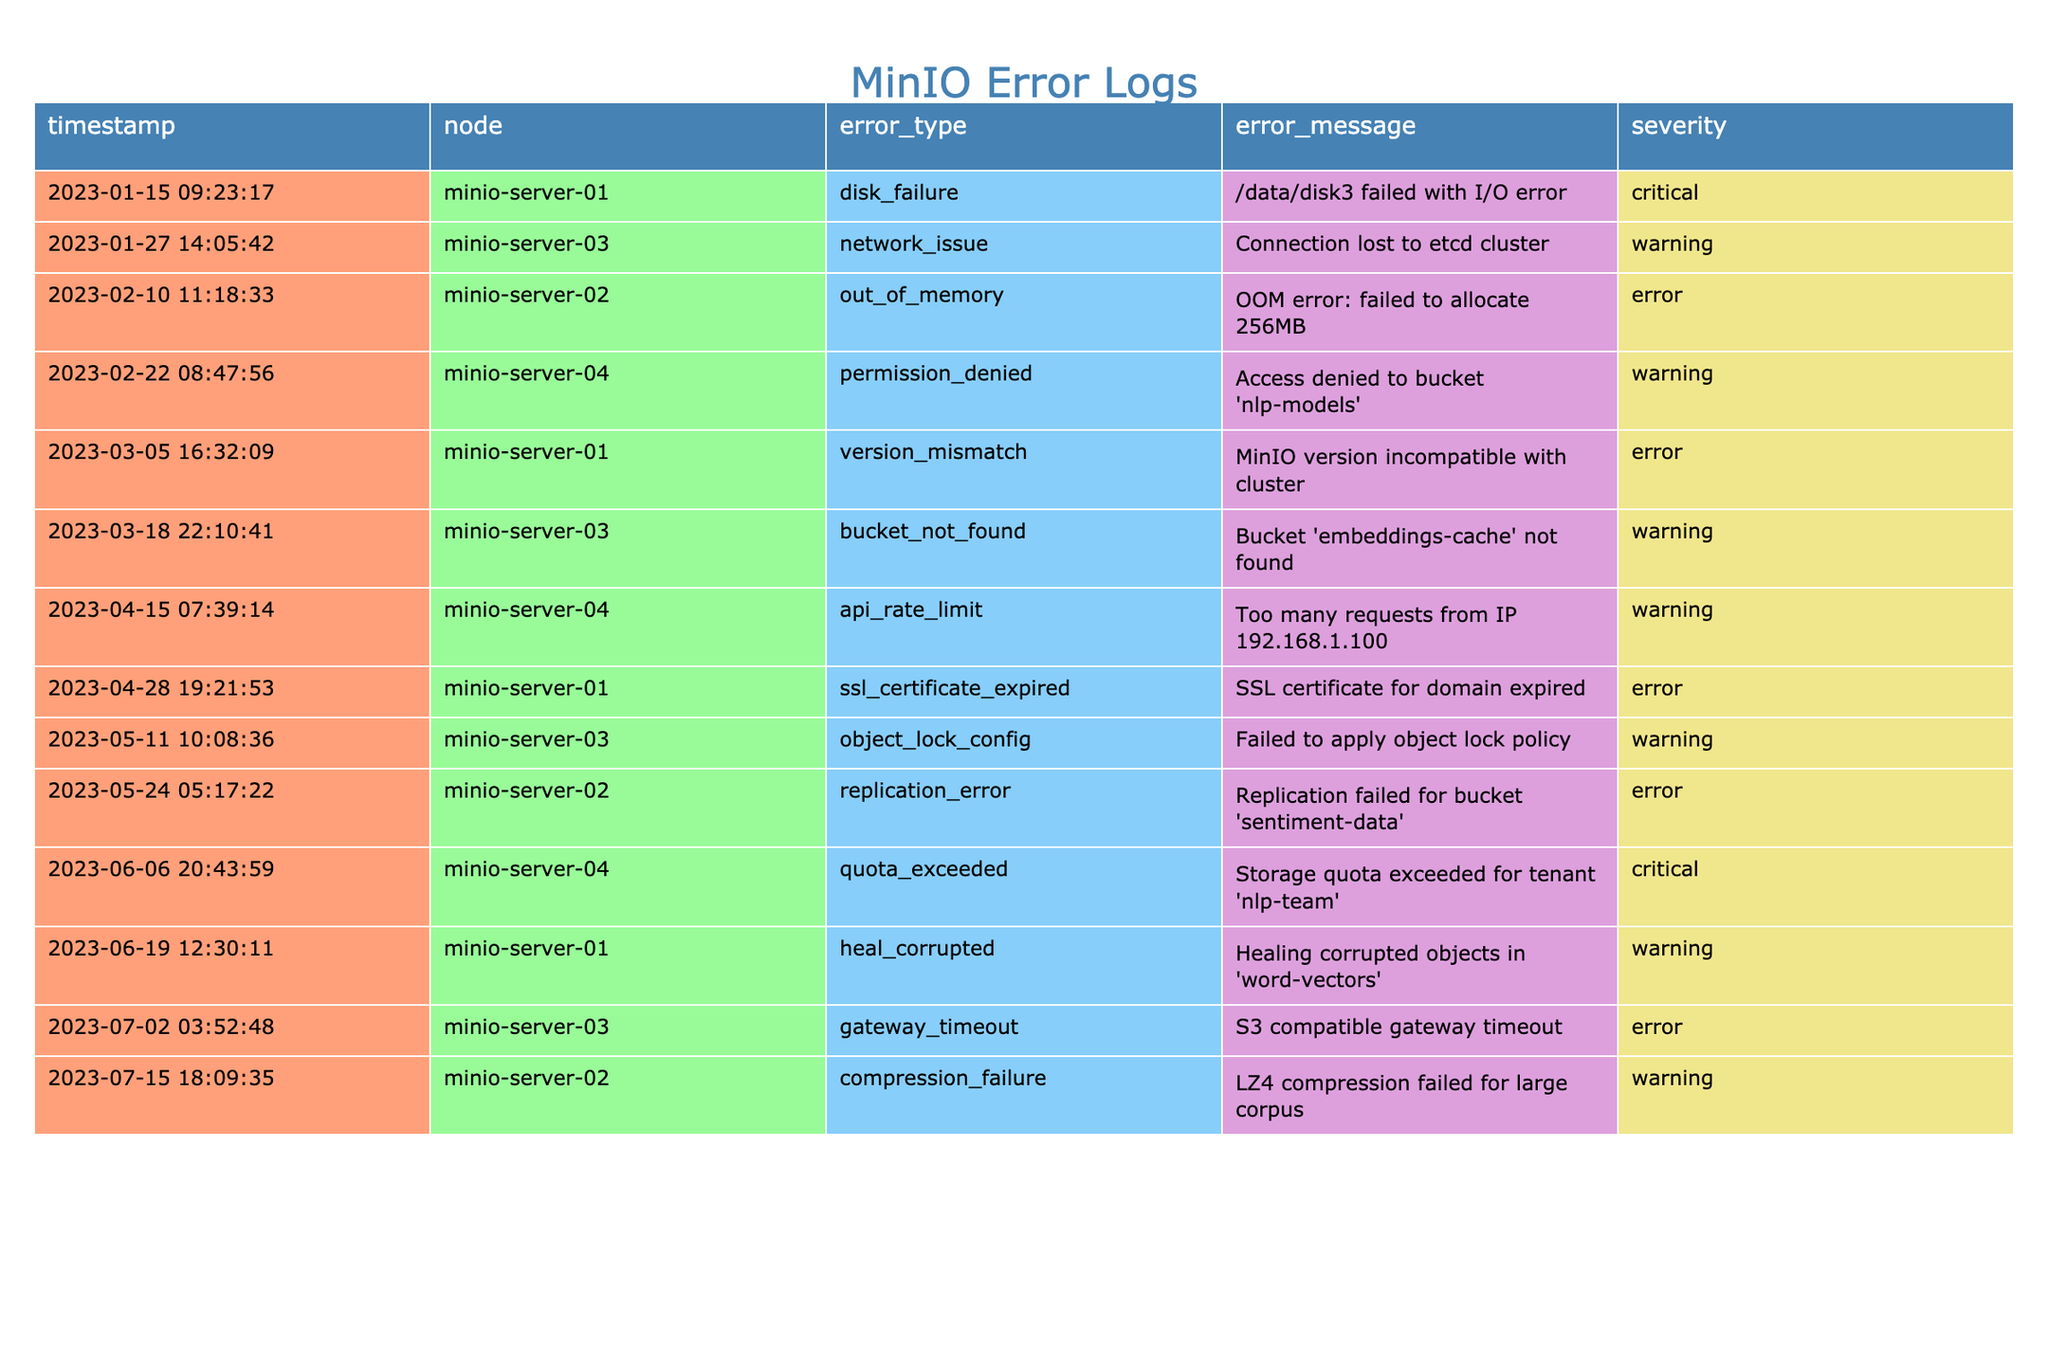What is the total number of error logs recorded? There are 14 entries in the table, each representing an individual error log during the 6-month period.
Answer: 14 Which node had the most severe errors? Observing the severity levels, MinIO server-01 had 2 critical errors (disk_failure and ssl_certificate_expired), while others had warning and error levels.
Answer: minio-server-01 How many warning messages are logged in total? There are 6 warning messages listed in the table from various nodes, indicating different issues.
Answer: 6 Was there any error related to "out_of_memory"? There is one entry regarding an "out_of_memory" error in the table, specifically for minio-server-02.
Answer: Yes What was the error message for the "api_rate_limit"? The error message associated with "api_rate_limit" is "Too many requests from IP 192.168.1.100" for minio-server-04.
Answer: Too many requests from IP 192.168.1.100 How many unique nodes reported errors? By evaluating the nodes listed in the table, there are 4 unique nodes (minio-server-01, minio-server-02, minio-server-03, minio-server-04) that recorded errors.
Answer: 4 What type of error occurred most frequently? Upon reviewing the error types, "warning" appears most frequently with 6 occurrences, compared to others like "error" and "critical".
Answer: warning Is there any instance of a "disk_failure"? Yes, the table shows a "disk_failure" message indicating an I/O error on "minio-server-01".
Answer: Yes What is the total count of critical error types? The table indicates there are 2 critical errors (disk_failure and quota_exceeded) reported across the logs.
Answer: 2 Which node had an error related to permissions? The error related to permissions occurred on minio-server-04, with the message stating "Access denied to bucket 'nlp-models'".
Answer: minio-server-04 Have there been any errors concerning "object_lock_config"? Yes, there is a warning relating to "object_lock_config", mentioning a failure to apply the policy for minio-server-03.
Answer: Yes Which error messages were classified as "critical"? The critical error messages are "disk_failure" on minio-server-01 and "quota_exceeded" on minio-server-04.
Answer: "disk_failure" and "quota_exceeded" 